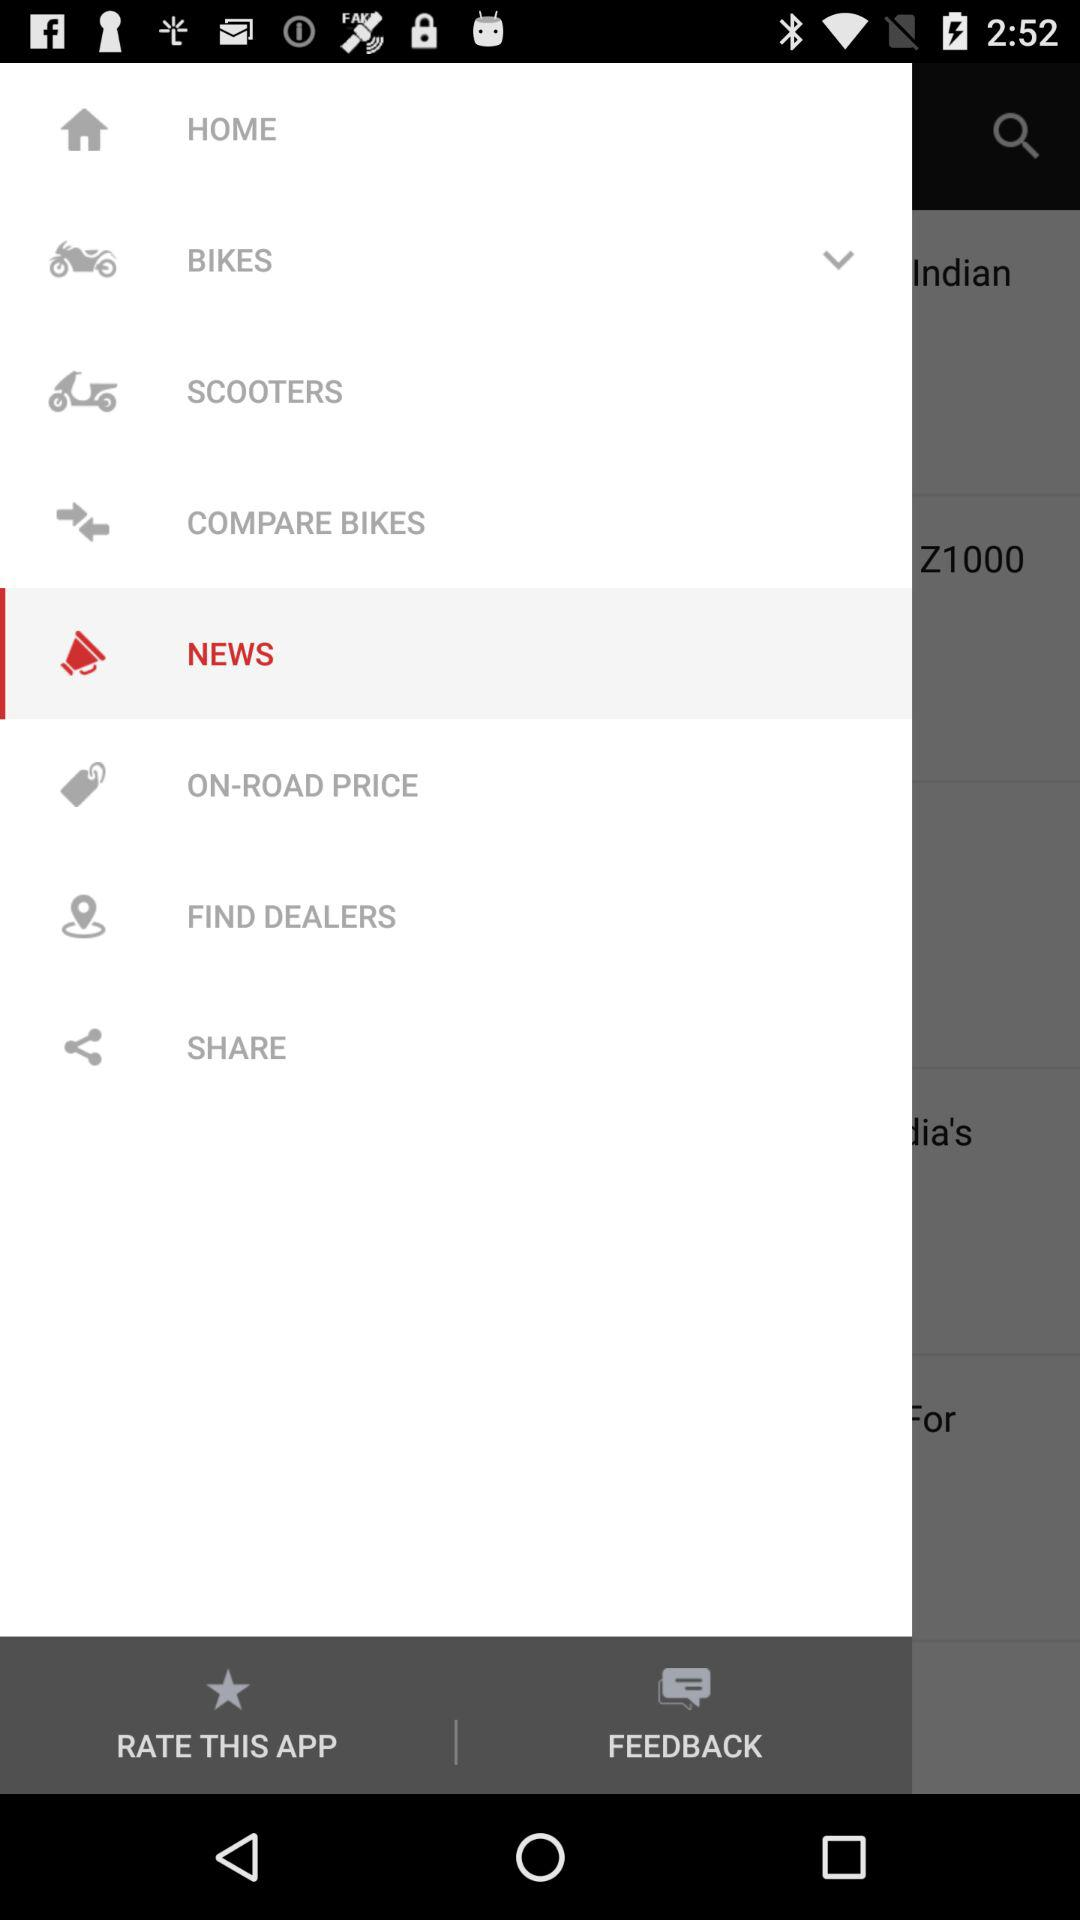Which is the selected option? The selected option is "NEWS". 